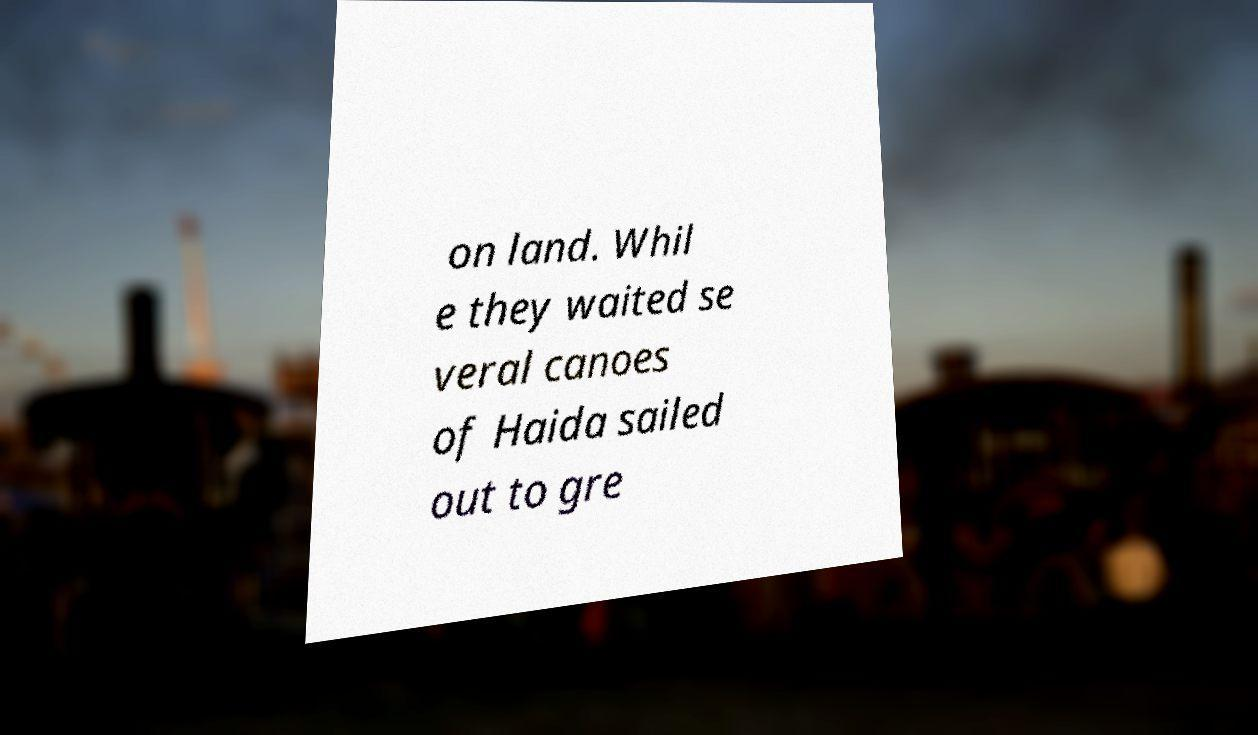For documentation purposes, I need the text within this image transcribed. Could you provide that? on land. Whil e they waited se veral canoes of Haida sailed out to gre 